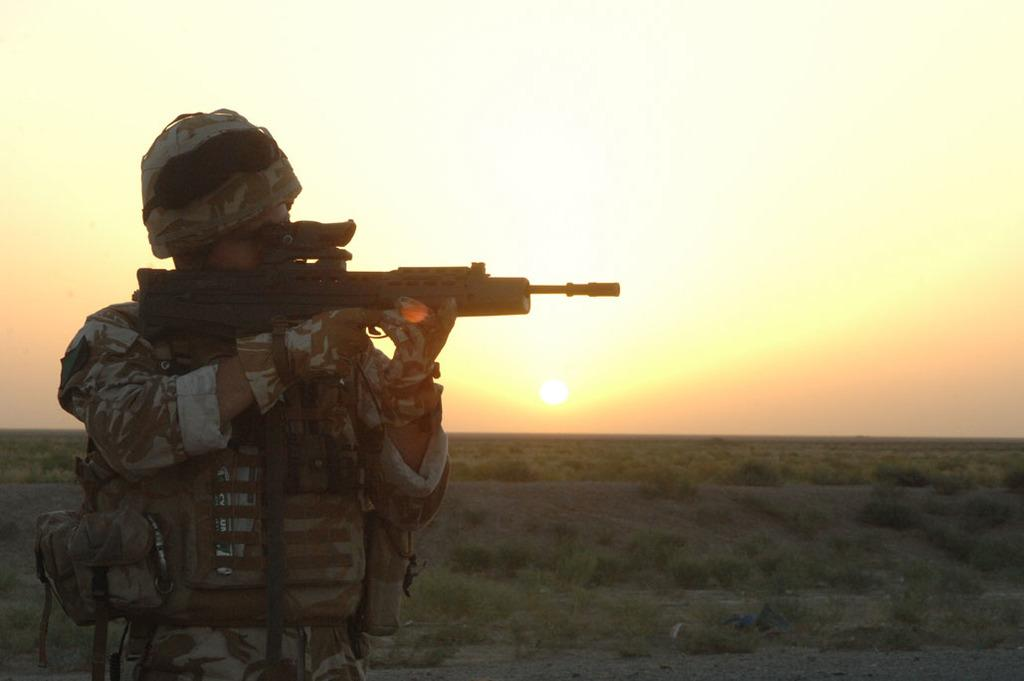What is the main subject of the image? The main subject of the image is a man. What is the man doing in the image? The man is standing in the image. What is the man holding in his hands? The man is holding a gun in his hands. What protective gear is the man wearing? The man is wearing a helmet in the image. What type of clothing is the man wearing? The man is wearing a uniform in the image. What other objects can be seen on the man? The man is wearing some other objects, but their specifics are not mentioned in the facts. What can be seen in the background of the image? The sun and the sky are visible in the background of the image. What type of disease is the man suffering from in the image? There is no indication of any disease in the image; the man is simply standing and holding a gun. 